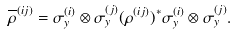<formula> <loc_0><loc_0><loc_500><loc_500>\overline { \rho } ^ { ( i j ) } = \sigma ^ { ( i ) } _ { y } \otimes \sigma ^ { ( j ) } _ { y } ( \rho ^ { ( i j ) } ) ^ { \ast } \sigma ^ { ( i ) } _ { y } \otimes \sigma ^ { ( j ) } _ { y } .</formula> 